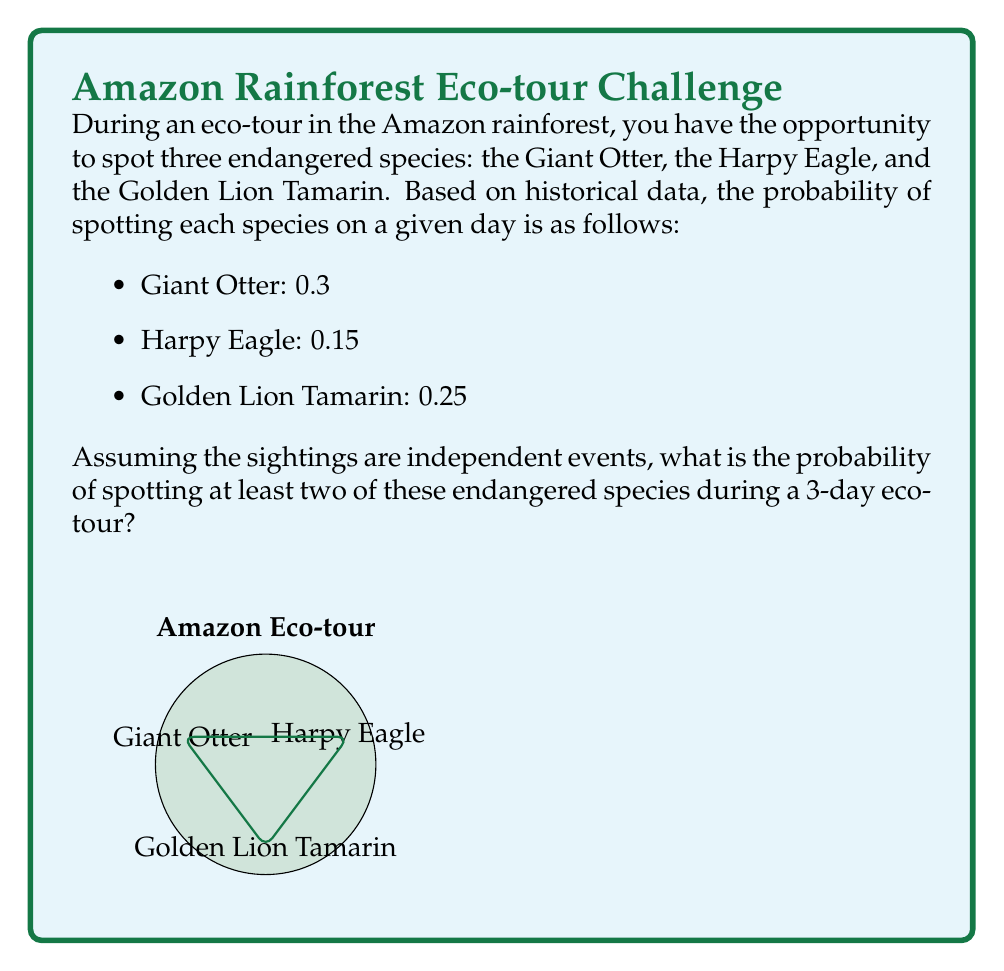Provide a solution to this math problem. Let's approach this step-by-step:

1) First, we need to calculate the probability of spotting each species at least once during the 3-day tour.

   For each species, the probability of not spotting it on a single day is:
   - Giant Otter: $1 - 0.3 = 0.7$
   - Harpy Eagle: $1 - 0.15 = 0.85$
   - Golden Lion Tamarin: $1 - 0.25 = 0.75$

   The probability of not spotting a species over 3 days is this value cubed:
   - Giant Otter: $0.7^3 = 0.343$
   - Harpy Eagle: $0.85^3 = 0.614125$
   - Golden Lion Tamarin: $0.75^3 = 0.421875$

   Therefore, the probability of spotting each species at least once in 3 days is:
   - Giant Otter: $1 - 0.343 = 0.657$
   - Harpy Eagle: $1 - 0.614125 = 0.385875$
   - Golden Lion Tamarin: $1 - 0.421875 = 0.578125$

2) Now, we can use the complementary event method. Instead of calculating the probability of spotting at least two species, we'll calculate the probability of spotting one or fewer species and subtract from 1.

3) The probability of spotting one or fewer species is the sum of:
   - The probability of spotting no species: 
     $(1-0.657)(1-0.385875)(1-0.578125) = 0.1080$
   - The probability of spotting only the Giant Otter: 
     $0.657(1-0.385875)(1-0.578125) = 0.1651$
   - The probability of spotting only the Harpy Eagle: 
     $(1-0.657)0.385875(1-0.578125) = 0.0668$
   - The probability of spotting only the Golden Lion Tamarin: 
     $(1-0.657)(1-0.385875)0.578125 = 0.1483$

4) Sum these probabilities: $0.1080 + 0.1651 + 0.0668 + 0.1483 = 0.4882$

5) The probability of spotting at least two species is the complement of this:
   $1 - 0.4882 = 0.5118$
Answer: $0.5118$ or approximately $51.18\%$ 